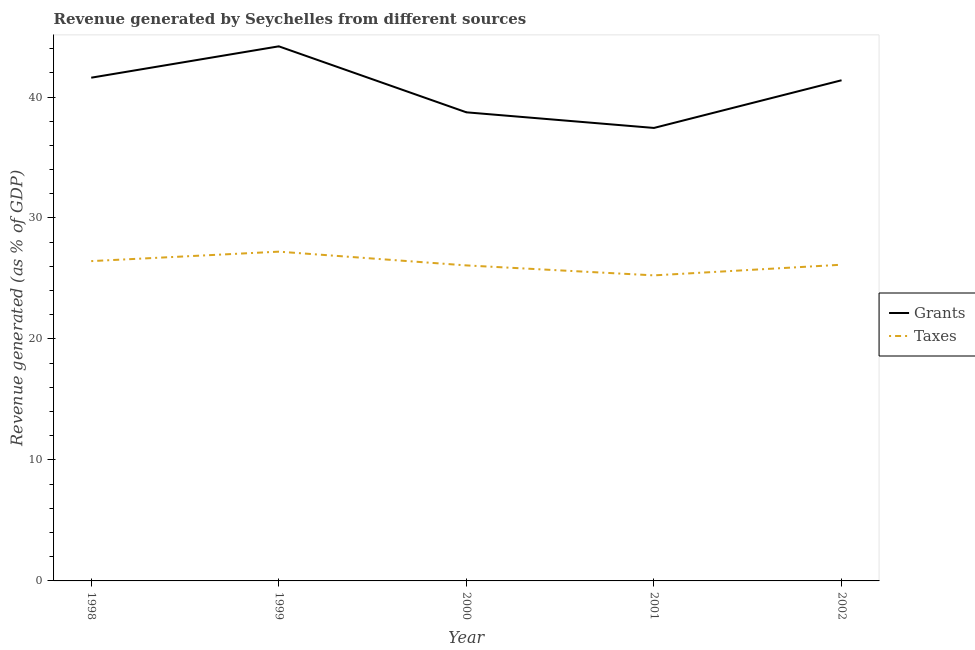How many different coloured lines are there?
Ensure brevity in your answer.  2. Does the line corresponding to revenue generated by grants intersect with the line corresponding to revenue generated by taxes?
Offer a terse response. No. What is the revenue generated by grants in 2002?
Ensure brevity in your answer.  41.38. Across all years, what is the maximum revenue generated by grants?
Offer a very short reply. 44.19. Across all years, what is the minimum revenue generated by grants?
Offer a very short reply. 37.44. In which year was the revenue generated by taxes minimum?
Your answer should be compact. 2001. What is the total revenue generated by grants in the graph?
Offer a terse response. 203.35. What is the difference between the revenue generated by taxes in 1998 and that in 2000?
Your answer should be very brief. 0.36. What is the difference between the revenue generated by taxes in 2002 and the revenue generated by grants in 2001?
Give a very brief answer. -11.31. What is the average revenue generated by taxes per year?
Give a very brief answer. 26.23. In the year 1998, what is the difference between the revenue generated by grants and revenue generated by taxes?
Give a very brief answer. 15.16. What is the ratio of the revenue generated by taxes in 1998 to that in 2000?
Your response must be concise. 1.01. Is the difference between the revenue generated by taxes in 1999 and 2002 greater than the difference between the revenue generated by grants in 1999 and 2002?
Offer a very short reply. No. What is the difference between the highest and the second highest revenue generated by grants?
Offer a very short reply. 2.59. What is the difference between the highest and the lowest revenue generated by grants?
Your response must be concise. 6.75. In how many years, is the revenue generated by grants greater than the average revenue generated by grants taken over all years?
Provide a short and direct response. 3. Does the revenue generated by grants monotonically increase over the years?
Provide a succinct answer. No. Is the revenue generated by grants strictly greater than the revenue generated by taxes over the years?
Keep it short and to the point. Yes. Is the revenue generated by grants strictly less than the revenue generated by taxes over the years?
Your answer should be compact. No. Does the graph contain any zero values?
Provide a succinct answer. No. Where does the legend appear in the graph?
Offer a very short reply. Center right. How many legend labels are there?
Your answer should be very brief. 2. What is the title of the graph?
Your answer should be compact. Revenue generated by Seychelles from different sources. Does "Export" appear as one of the legend labels in the graph?
Keep it short and to the point. No. What is the label or title of the Y-axis?
Give a very brief answer. Revenue generated (as % of GDP). What is the Revenue generated (as % of GDP) of Grants in 1998?
Keep it short and to the point. 41.6. What is the Revenue generated (as % of GDP) of Taxes in 1998?
Your answer should be very brief. 26.44. What is the Revenue generated (as % of GDP) of Grants in 1999?
Offer a terse response. 44.19. What is the Revenue generated (as % of GDP) in Taxes in 1999?
Your answer should be compact. 27.22. What is the Revenue generated (as % of GDP) of Grants in 2000?
Make the answer very short. 38.74. What is the Revenue generated (as % of GDP) of Taxes in 2000?
Ensure brevity in your answer.  26.08. What is the Revenue generated (as % of GDP) of Grants in 2001?
Keep it short and to the point. 37.44. What is the Revenue generated (as % of GDP) in Taxes in 2001?
Your answer should be very brief. 25.26. What is the Revenue generated (as % of GDP) in Grants in 2002?
Provide a short and direct response. 41.38. What is the Revenue generated (as % of GDP) in Taxes in 2002?
Your answer should be compact. 26.14. Across all years, what is the maximum Revenue generated (as % of GDP) in Grants?
Give a very brief answer. 44.19. Across all years, what is the maximum Revenue generated (as % of GDP) in Taxes?
Keep it short and to the point. 27.22. Across all years, what is the minimum Revenue generated (as % of GDP) in Grants?
Offer a terse response. 37.44. Across all years, what is the minimum Revenue generated (as % of GDP) of Taxes?
Give a very brief answer. 25.26. What is the total Revenue generated (as % of GDP) of Grants in the graph?
Provide a succinct answer. 203.35. What is the total Revenue generated (as % of GDP) of Taxes in the graph?
Ensure brevity in your answer.  131.13. What is the difference between the Revenue generated (as % of GDP) of Grants in 1998 and that in 1999?
Your answer should be compact. -2.59. What is the difference between the Revenue generated (as % of GDP) in Taxes in 1998 and that in 1999?
Offer a very short reply. -0.78. What is the difference between the Revenue generated (as % of GDP) in Grants in 1998 and that in 2000?
Give a very brief answer. 2.86. What is the difference between the Revenue generated (as % of GDP) of Taxes in 1998 and that in 2000?
Your response must be concise. 0.36. What is the difference between the Revenue generated (as % of GDP) in Grants in 1998 and that in 2001?
Provide a short and direct response. 4.15. What is the difference between the Revenue generated (as % of GDP) of Taxes in 1998 and that in 2001?
Offer a terse response. 1.18. What is the difference between the Revenue generated (as % of GDP) in Grants in 1998 and that in 2002?
Offer a very short reply. 0.21. What is the difference between the Revenue generated (as % of GDP) in Taxes in 1998 and that in 2002?
Offer a terse response. 0.3. What is the difference between the Revenue generated (as % of GDP) in Grants in 1999 and that in 2000?
Keep it short and to the point. 5.46. What is the difference between the Revenue generated (as % of GDP) in Taxes in 1999 and that in 2000?
Ensure brevity in your answer.  1.14. What is the difference between the Revenue generated (as % of GDP) of Grants in 1999 and that in 2001?
Provide a succinct answer. 6.75. What is the difference between the Revenue generated (as % of GDP) of Taxes in 1999 and that in 2001?
Make the answer very short. 1.96. What is the difference between the Revenue generated (as % of GDP) of Grants in 1999 and that in 2002?
Provide a short and direct response. 2.81. What is the difference between the Revenue generated (as % of GDP) of Taxes in 1999 and that in 2002?
Your answer should be very brief. 1.08. What is the difference between the Revenue generated (as % of GDP) of Grants in 2000 and that in 2001?
Make the answer very short. 1.29. What is the difference between the Revenue generated (as % of GDP) of Taxes in 2000 and that in 2001?
Give a very brief answer. 0.82. What is the difference between the Revenue generated (as % of GDP) of Grants in 2000 and that in 2002?
Keep it short and to the point. -2.65. What is the difference between the Revenue generated (as % of GDP) of Taxes in 2000 and that in 2002?
Your response must be concise. -0.06. What is the difference between the Revenue generated (as % of GDP) of Grants in 2001 and that in 2002?
Your response must be concise. -3.94. What is the difference between the Revenue generated (as % of GDP) in Taxes in 2001 and that in 2002?
Provide a succinct answer. -0.88. What is the difference between the Revenue generated (as % of GDP) of Grants in 1998 and the Revenue generated (as % of GDP) of Taxes in 1999?
Give a very brief answer. 14.38. What is the difference between the Revenue generated (as % of GDP) in Grants in 1998 and the Revenue generated (as % of GDP) in Taxes in 2000?
Your response must be concise. 15.52. What is the difference between the Revenue generated (as % of GDP) in Grants in 1998 and the Revenue generated (as % of GDP) in Taxes in 2001?
Provide a short and direct response. 16.34. What is the difference between the Revenue generated (as % of GDP) of Grants in 1998 and the Revenue generated (as % of GDP) of Taxes in 2002?
Ensure brevity in your answer.  15.46. What is the difference between the Revenue generated (as % of GDP) in Grants in 1999 and the Revenue generated (as % of GDP) in Taxes in 2000?
Your answer should be very brief. 18.11. What is the difference between the Revenue generated (as % of GDP) of Grants in 1999 and the Revenue generated (as % of GDP) of Taxes in 2001?
Offer a very short reply. 18.93. What is the difference between the Revenue generated (as % of GDP) in Grants in 1999 and the Revenue generated (as % of GDP) in Taxes in 2002?
Offer a terse response. 18.05. What is the difference between the Revenue generated (as % of GDP) of Grants in 2000 and the Revenue generated (as % of GDP) of Taxes in 2001?
Provide a succinct answer. 13.48. What is the difference between the Revenue generated (as % of GDP) of Grants in 2000 and the Revenue generated (as % of GDP) of Taxes in 2002?
Your response must be concise. 12.6. What is the difference between the Revenue generated (as % of GDP) in Grants in 2001 and the Revenue generated (as % of GDP) in Taxes in 2002?
Provide a short and direct response. 11.31. What is the average Revenue generated (as % of GDP) in Grants per year?
Your answer should be compact. 40.67. What is the average Revenue generated (as % of GDP) of Taxes per year?
Keep it short and to the point. 26.23. In the year 1998, what is the difference between the Revenue generated (as % of GDP) in Grants and Revenue generated (as % of GDP) in Taxes?
Give a very brief answer. 15.16. In the year 1999, what is the difference between the Revenue generated (as % of GDP) of Grants and Revenue generated (as % of GDP) of Taxes?
Your answer should be very brief. 16.97. In the year 2000, what is the difference between the Revenue generated (as % of GDP) in Grants and Revenue generated (as % of GDP) in Taxes?
Ensure brevity in your answer.  12.65. In the year 2001, what is the difference between the Revenue generated (as % of GDP) in Grants and Revenue generated (as % of GDP) in Taxes?
Give a very brief answer. 12.19. In the year 2002, what is the difference between the Revenue generated (as % of GDP) of Grants and Revenue generated (as % of GDP) of Taxes?
Your answer should be very brief. 15.25. What is the ratio of the Revenue generated (as % of GDP) of Grants in 1998 to that in 1999?
Provide a succinct answer. 0.94. What is the ratio of the Revenue generated (as % of GDP) of Taxes in 1998 to that in 1999?
Provide a short and direct response. 0.97. What is the ratio of the Revenue generated (as % of GDP) of Grants in 1998 to that in 2000?
Make the answer very short. 1.07. What is the ratio of the Revenue generated (as % of GDP) in Taxes in 1998 to that in 2000?
Your answer should be compact. 1.01. What is the ratio of the Revenue generated (as % of GDP) of Grants in 1998 to that in 2001?
Provide a succinct answer. 1.11. What is the ratio of the Revenue generated (as % of GDP) of Taxes in 1998 to that in 2001?
Offer a terse response. 1.05. What is the ratio of the Revenue generated (as % of GDP) in Grants in 1998 to that in 2002?
Your answer should be very brief. 1.01. What is the ratio of the Revenue generated (as % of GDP) in Taxes in 1998 to that in 2002?
Provide a short and direct response. 1.01. What is the ratio of the Revenue generated (as % of GDP) of Grants in 1999 to that in 2000?
Offer a very short reply. 1.14. What is the ratio of the Revenue generated (as % of GDP) of Taxes in 1999 to that in 2000?
Keep it short and to the point. 1.04. What is the ratio of the Revenue generated (as % of GDP) of Grants in 1999 to that in 2001?
Provide a short and direct response. 1.18. What is the ratio of the Revenue generated (as % of GDP) of Taxes in 1999 to that in 2001?
Your response must be concise. 1.08. What is the ratio of the Revenue generated (as % of GDP) in Grants in 1999 to that in 2002?
Your response must be concise. 1.07. What is the ratio of the Revenue generated (as % of GDP) of Taxes in 1999 to that in 2002?
Your response must be concise. 1.04. What is the ratio of the Revenue generated (as % of GDP) in Grants in 2000 to that in 2001?
Ensure brevity in your answer.  1.03. What is the ratio of the Revenue generated (as % of GDP) in Taxes in 2000 to that in 2001?
Ensure brevity in your answer.  1.03. What is the ratio of the Revenue generated (as % of GDP) in Grants in 2000 to that in 2002?
Your answer should be compact. 0.94. What is the ratio of the Revenue generated (as % of GDP) in Taxes in 2000 to that in 2002?
Keep it short and to the point. 1. What is the ratio of the Revenue generated (as % of GDP) of Grants in 2001 to that in 2002?
Provide a short and direct response. 0.9. What is the ratio of the Revenue generated (as % of GDP) of Taxes in 2001 to that in 2002?
Your answer should be compact. 0.97. What is the difference between the highest and the second highest Revenue generated (as % of GDP) in Grants?
Ensure brevity in your answer.  2.59. What is the difference between the highest and the second highest Revenue generated (as % of GDP) in Taxes?
Provide a short and direct response. 0.78. What is the difference between the highest and the lowest Revenue generated (as % of GDP) in Grants?
Keep it short and to the point. 6.75. What is the difference between the highest and the lowest Revenue generated (as % of GDP) of Taxes?
Provide a short and direct response. 1.96. 